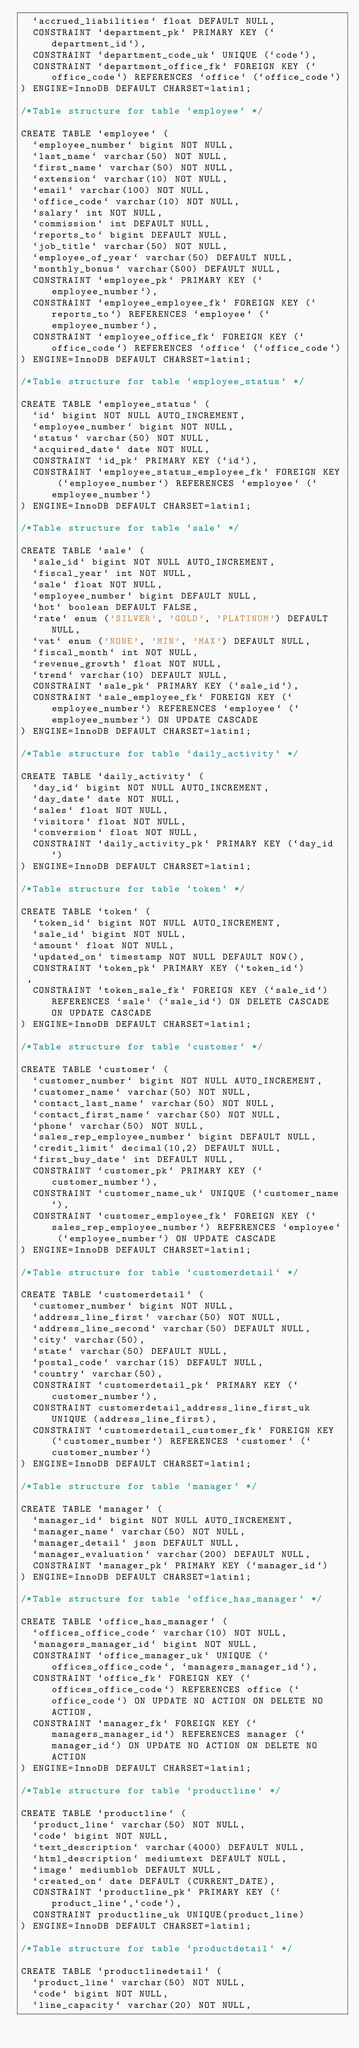Convert code to text. <code><loc_0><loc_0><loc_500><loc_500><_SQL_>  `accrued_liabilities` float DEFAULT NULL,
  CONSTRAINT `department_pk` PRIMARY KEY (`department_id`),  
  CONSTRAINT `department_code_uk` UNIQUE (`code`),
  CONSTRAINT `department_office_fk` FOREIGN KEY (`office_code`) REFERENCES `office` (`office_code`)
) ENGINE=InnoDB DEFAULT CHARSET=latin1;

/*Table structure for table `employee` */

CREATE TABLE `employee` (
  `employee_number` bigint NOT NULL,
  `last_name` varchar(50) NOT NULL,
  `first_name` varchar(50) NOT NULL,
  `extension` varchar(10) NOT NULL,
  `email` varchar(100) NOT NULL,
  `office_code` varchar(10) NOT NULL,
  `salary` int NOT NULL,
  `commission` int DEFAULT NULL,
  `reports_to` bigint DEFAULT NULL,
  `job_title` varchar(50) NOT NULL, 
  `employee_of_year` varchar(50) DEFAULT NULL,
  `monthly_bonus` varchar(500) DEFAULT NULL,
  CONSTRAINT `employee_pk` PRIMARY KEY (`employee_number`),
  CONSTRAINT `employee_employee_fk` FOREIGN KEY (`reports_to`) REFERENCES `employee` (`employee_number`),
  CONSTRAINT `employee_office_fk` FOREIGN KEY (`office_code`) REFERENCES `office` (`office_code`)
) ENGINE=InnoDB DEFAULT CHARSET=latin1;

/*Table structure for table `employee_status` */

CREATE TABLE `employee_status` (
  `id` bigint NOT NULL AUTO_INCREMENT,
  `employee_number` bigint NOT NULL,  
  `status` varchar(50) NOT NULL,  
  `acquired_date` date NOT NULL,
  CONSTRAINT `id_pk` PRIMARY KEY (`id`),  
  CONSTRAINT `employee_status_employee_fk` FOREIGN KEY (`employee_number`) REFERENCES `employee` (`employee_number`)
) ENGINE=InnoDB DEFAULT CHARSET=latin1;

/*Table structure for table `sale` */

CREATE TABLE `sale` (
  `sale_id` bigint NOT NULL AUTO_INCREMENT, 
  `fiscal_year` int NOT NULL,  
  `sale` float NOT NULL,  
  `employee_number` bigint DEFAULT NULL,  
  `hot` boolean DEFAULT FALSE,  
  `rate` enum ('SILVER', 'GOLD', 'PLATINUM') DEFAULT NULL,
  `vat` enum ('NONE', 'MIN', 'MAX') DEFAULT NULL,
  `fiscal_month` int NOT NULL,
  `revenue_growth` float NOT NULL, 
  `trend` varchar(10) DEFAULT NULL,
  CONSTRAINT `sale_pk` PRIMARY KEY (`sale_id`),    
  CONSTRAINT `sale_employee_fk` FOREIGN KEY (`employee_number`) REFERENCES `employee` (`employee_number`) ON UPDATE CASCADE
) ENGINE=InnoDB DEFAULT CHARSET=latin1;

/*Table structure for table `daily_activity` */

CREATE TABLE `daily_activity` (
  `day_id` bigint NOT NULL AUTO_INCREMENT, 
  `day_date` date NOT NULL,
  `sales` float NOT NULL,  
  `visitors` float NOT NULL,    
  `conversion` float NOT NULL,
  CONSTRAINT `daily_activity_pk` PRIMARY KEY (`day_id`)
) ENGINE=InnoDB DEFAULT CHARSET=latin1;

/*Table structure for table `token` */

CREATE TABLE `token` (
  `token_id` bigint NOT NULL AUTO_INCREMENT,    
  `sale_id` bigint NOT NULL,
  `amount` float NOT NULL,   
  `updated_on` timestamp NOT NULL DEFAULT NOW(),
  CONSTRAINT `token_pk` PRIMARY KEY (`token_id`)
 ,  
  CONSTRAINT `token_sale_fk` FOREIGN KEY (`sale_id`) REFERENCES `sale` (`sale_id`) ON DELETE CASCADE ON UPDATE CASCADE
) ENGINE=InnoDB DEFAULT CHARSET=latin1;

/*Table structure for table `customer` */

CREATE TABLE `customer` (
  `customer_number` bigint NOT NULL AUTO_INCREMENT,
  `customer_name` varchar(50) NOT NULL,
  `contact_last_name` varchar(50) NOT NULL,
  `contact_first_name` varchar(50) NOT NULL,
  `phone` varchar(50) NOT NULL,
  `sales_rep_employee_number` bigint DEFAULT NULL,
  `credit_limit` decimal(10,2) DEFAULT NULL,
  `first_buy_date` int DEFAULT NULL,
  CONSTRAINT `customer_pk` PRIMARY KEY (`customer_number`), 
  CONSTRAINT `customer_name_uk` UNIQUE (`customer_name`),
  CONSTRAINT `customer_employee_fk` FOREIGN KEY (`sales_rep_employee_number`) REFERENCES `employee` (`employee_number`) ON UPDATE CASCADE
) ENGINE=InnoDB DEFAULT CHARSET=latin1;

/*Table structure for table `customerdetail` */

CREATE TABLE `customerdetail` (
  `customer_number` bigint NOT NULL,
  `address_line_first` varchar(50) NOT NULL,
  `address_line_second` varchar(50) DEFAULT NULL,
  `city` varchar(50),
  `state` varchar(50) DEFAULT NULL,
  `postal_code` varchar(15) DEFAULT NULL,
  `country` varchar(50),
  CONSTRAINT `customerdetail_pk` PRIMARY KEY (`customer_number`),  
  CONSTRAINT customerdetail_address_line_first_uk UNIQUE (address_line_first),
  CONSTRAINT `customerdetail_customer_fk` FOREIGN KEY (`customer_number`) REFERENCES `customer` (`customer_number`)  
) ENGINE=InnoDB DEFAULT CHARSET=latin1;

/*Table structure for table `manager` */

CREATE TABLE `manager` (
  `manager_id` bigint NOT NULL AUTO_INCREMENT,
  `manager_name` varchar(50) NOT NULL,
  `manager_detail` json DEFAULT NULL,
  `manager_evaluation` varchar(200) DEFAULT NULL, 
  CONSTRAINT `manager_pk` PRIMARY KEY (`manager_id`)
) ENGINE=InnoDB DEFAULT CHARSET=latin1;

/*Table structure for table `office_has_manager` */

CREATE TABLE `office_has_manager` (
  `offices_office_code` varchar(10) NOT NULL,
  `managers_manager_id` bigint NOT NULL,
  CONSTRAINT `office_manager_uk` UNIQUE (`offices_office_code`, `managers_manager_id`),
  CONSTRAINT `office_fk` FOREIGN KEY (`offices_office_code`) REFERENCES office (`office_code`) ON UPDATE NO ACTION ON DELETE NO ACTION,
  CONSTRAINT `manager_fk` FOREIGN KEY (`managers_manager_id`) REFERENCES manager (`manager_id`) ON UPDATE NO ACTION ON DELETE NO ACTION  
) ENGINE=InnoDB DEFAULT CHARSET=latin1;

/*Table structure for table `productline` */

CREATE TABLE `productline` (
  `product_line` varchar(50) NOT NULL,
  `code` bigint NOT NULL,
  `text_description` varchar(4000) DEFAULT NULL,
  `html_description` mediumtext DEFAULT NULL,
  `image` mediumblob DEFAULT NULL,
  `created_on` date DEFAULT (CURRENT_DATE),
  CONSTRAINT `productline_pk` PRIMARY KEY (`product_line`,`code`),
  CONSTRAINT productline_uk UNIQUE(product_line)
) ENGINE=InnoDB DEFAULT CHARSET=latin1;

/*Table structure for table `productdetail` */

CREATE TABLE `productlinedetail` (
  `product_line` varchar(50) NOT NULL,
  `code` bigint NOT NULL,
  `line_capacity` varchar(20) NOT NULL,</code> 